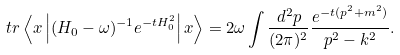<formula> <loc_0><loc_0><loc_500><loc_500>t r \left \langle { x } \left | ( H _ { 0 } - \omega ) ^ { - 1 } e ^ { - t H _ { 0 } ^ { 2 } } \right | { x } \right \rangle = 2 \omega \int \frac { d ^ { 2 } p } { ( 2 \pi ) ^ { 2 } } \frac { e ^ { - t ( p ^ { 2 } + m ^ { 2 } ) } } { p ^ { 2 } - k ^ { 2 } } .</formula> 